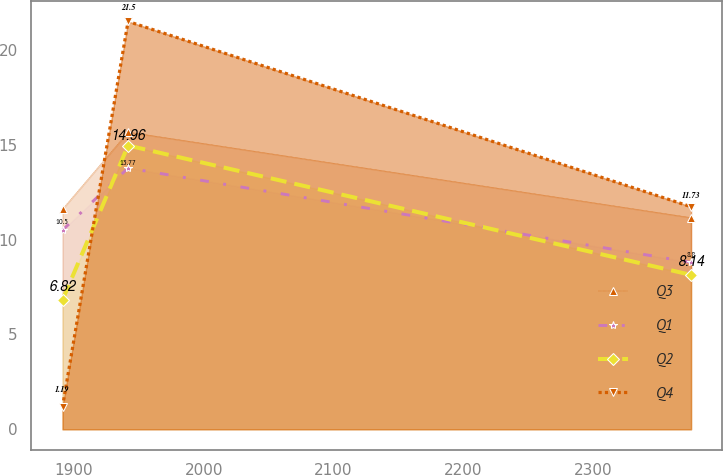Convert chart. <chart><loc_0><loc_0><loc_500><loc_500><line_chart><ecel><fcel>Q3<fcel>Q1<fcel>Q2<fcel>Q4<nl><fcel>1891.26<fcel>11.61<fcel>10.5<fcel>6.82<fcel>1.19<nl><fcel>1941.74<fcel>15.67<fcel>13.77<fcel>14.96<fcel>21.5<nl><fcel>2375.32<fcel>11.16<fcel>8.8<fcel>8.14<fcel>11.73<nl></chart> 